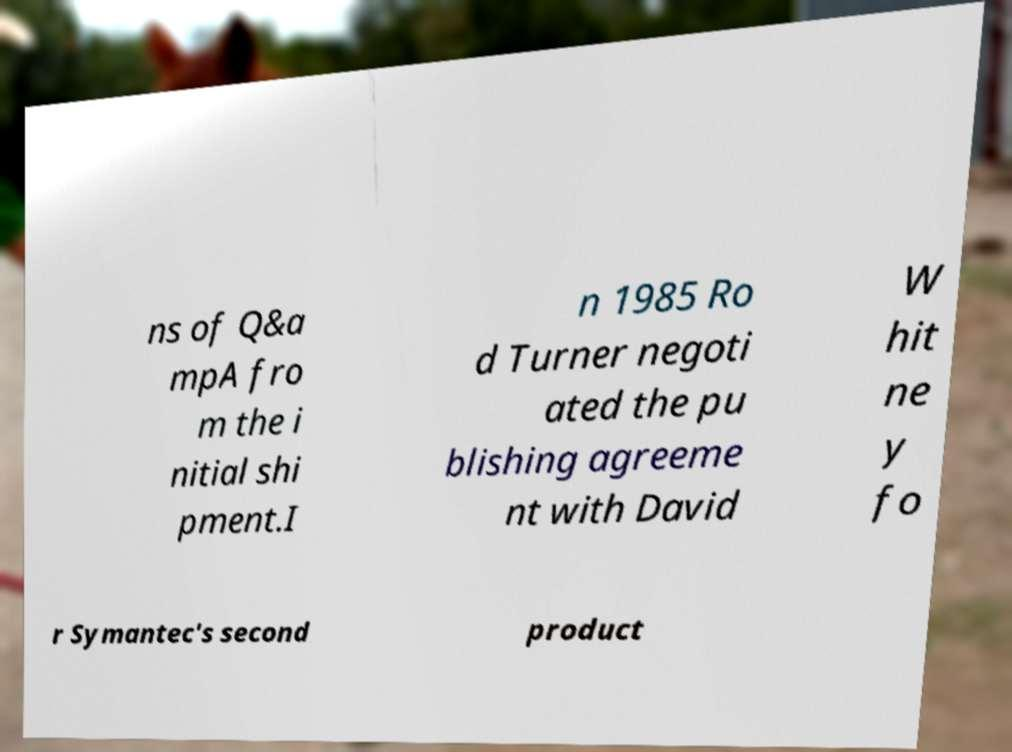There's text embedded in this image that I need extracted. Can you transcribe it verbatim? ns of Q&a mpA fro m the i nitial shi pment.I n 1985 Ro d Turner negoti ated the pu blishing agreeme nt with David W hit ne y fo r Symantec's second product 